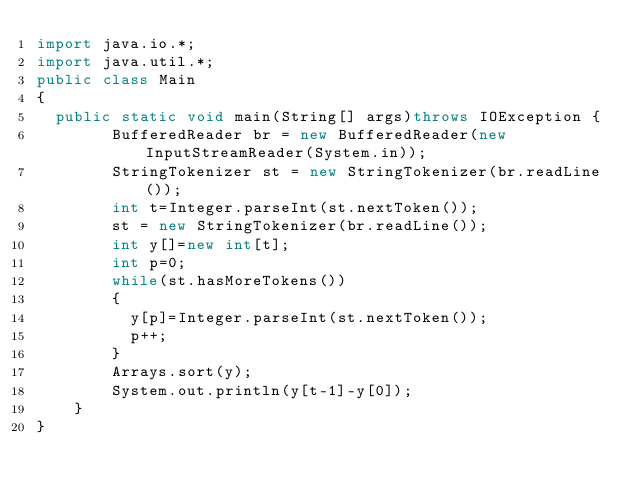Convert code to text. <code><loc_0><loc_0><loc_500><loc_500><_Java_>import java.io.*;
import java.util.*;
public class Main
{
	public static void main(String[] args)throws IOException {
        BufferedReader br = new BufferedReader(new InputStreamReader(System.in));
        StringTokenizer st = new StringTokenizer(br.readLine());
        int t=Integer.parseInt(st.nextToken());
      	st = new StringTokenizer(br.readLine());
      	int y[]=new int[t];
      	int p=0;
      	while(st.hasMoreTokens())
        {
          y[p]=Integer.parseInt(st.nextToken());
          p++;
        }
      	Arrays.sort(y);
      	System.out.println(y[t-1]-y[0]);
    }
}</code> 